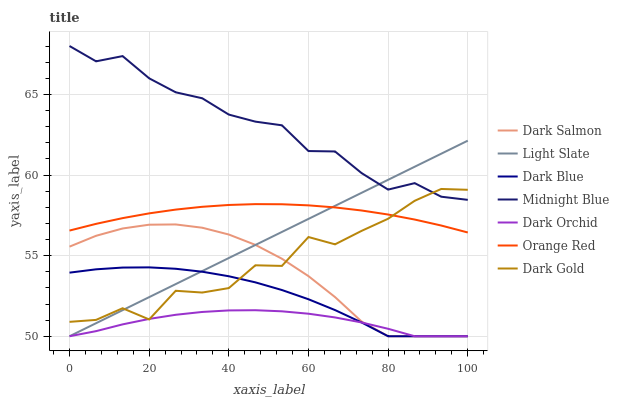Does Dark Orchid have the minimum area under the curve?
Answer yes or no. Yes. Does Midnight Blue have the maximum area under the curve?
Answer yes or no. Yes. Does Dark Gold have the minimum area under the curve?
Answer yes or no. No. Does Dark Gold have the maximum area under the curve?
Answer yes or no. No. Is Light Slate the smoothest?
Answer yes or no. Yes. Is Dark Gold the roughest?
Answer yes or no. Yes. Is Dark Gold the smoothest?
Answer yes or no. No. Is Light Slate the roughest?
Answer yes or no. No. Does Light Slate have the lowest value?
Answer yes or no. Yes. Does Dark Gold have the lowest value?
Answer yes or no. No. Does Midnight Blue have the highest value?
Answer yes or no. Yes. Does Dark Gold have the highest value?
Answer yes or no. No. Is Dark Salmon less than Midnight Blue?
Answer yes or no. Yes. Is Midnight Blue greater than Orange Red?
Answer yes or no. Yes. Does Orange Red intersect Light Slate?
Answer yes or no. Yes. Is Orange Red less than Light Slate?
Answer yes or no. No. Is Orange Red greater than Light Slate?
Answer yes or no. No. Does Dark Salmon intersect Midnight Blue?
Answer yes or no. No. 